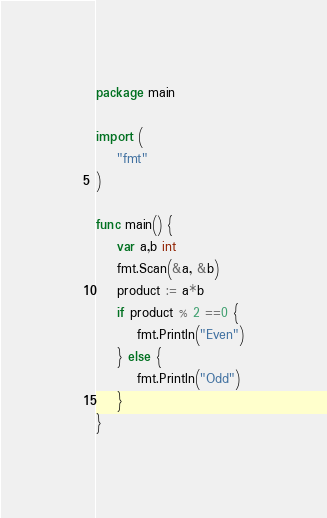<code> <loc_0><loc_0><loc_500><loc_500><_Go_>package main

import (
    "fmt"
)

func main() {
	var a,b int
	fmt.Scan(&a, &b)
	product := a*b 
	if product % 2 ==0 {
		fmt.Println("Even")
	} else {
		fmt.Println("Odd")
	}
}</code> 